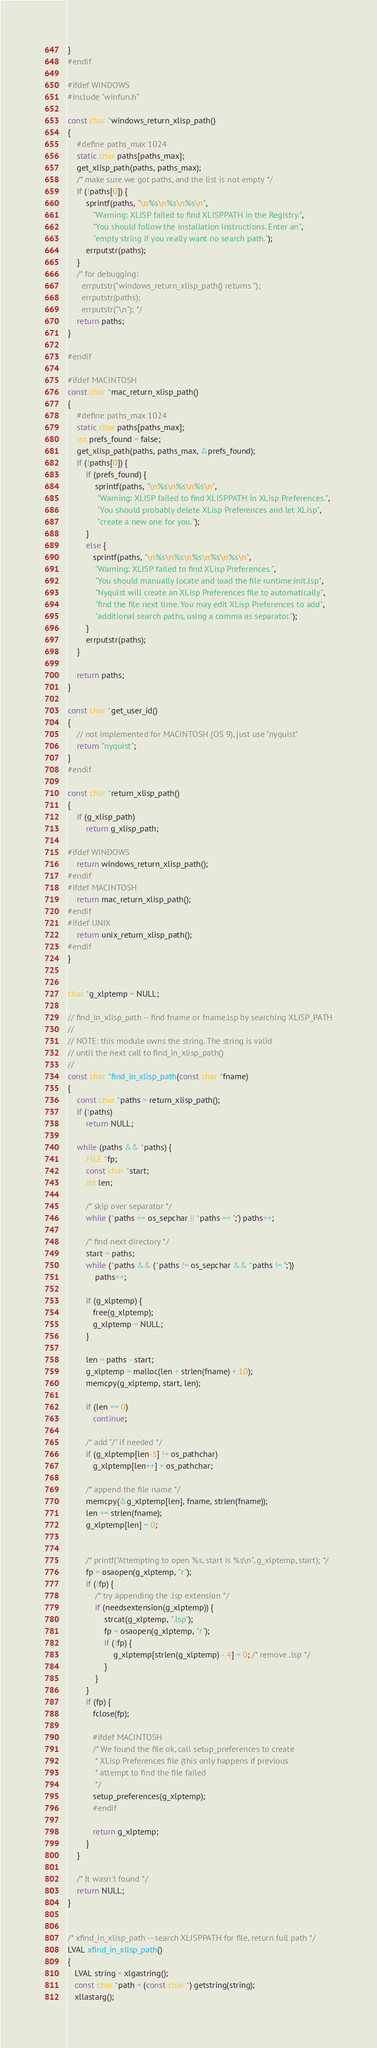Convert code to text. <code><loc_0><loc_0><loc_500><loc_500><_C_>}
#endif

#ifdef WINDOWS
#include "winfun.h"

const char *windows_return_xlisp_path()
{
    #define paths_max 1024
    static char paths[paths_max];
    get_xlisp_path(paths, paths_max);
    /* make sure we got paths, and the list is not empty */
    if (!paths[0]) {
        sprintf(paths, "\n%s\n%s\n%s\n",
           "Warning: XLISP failed to find XLISPPATH in the Registry.",
           "You should follow the installation instructions. Enter an",
           "empty string if you really want no search path.");
        errputstr(paths);
    }
    /* for debugging: 
      errputstr("windows_return_xlisp_path() returns ");
      errputstr(paths);
      errputstr("\n"); */
    return paths;
}

#endif

#ifdef MACINTOSH
const char *mac_return_xlisp_path()
{
    #define paths_max 1024
    static char paths[paths_max];
    int prefs_found = false;
    get_xlisp_path(paths, paths_max, &prefs_found);
    if (!paths[0]) {
        if (prefs_found) {
            sprintf(paths, "\n%s\n%s\n%s\n",
             "Warning: XLISP failed to find XLISPPATH in XLisp Preferences.",
             "You should probably delete XLisp Preferences and let XLisp",
             "create a new one for you.");
        }
        else {
           sprintf(paths, "\n%s\n%s\n%s\n%s\n%s\n",
            "Warning: XLISP failed to find XLisp Preferences.",
            "You should manually locate and load the file runtime:init.lsp",
            "Nyquist will create an XLisp Preferences file to automatically",
            "find the file next time. You may edit XLisp Preferences to add",
            "additional search paths, using a comma as separator.");
        }
        errputstr(paths);
    }

    return paths;
}

const char *get_user_id()
{
    // not implemented for MACINTOSH (OS 9), just use "nyquist"
    return "nyquist";
}
#endif

const char *return_xlisp_path()
{
    if (g_xlisp_path)
        return g_xlisp_path;

#ifdef WINDOWS
    return windows_return_xlisp_path();
#endif
#ifdef MACINTOSH
    return mac_return_xlisp_path();
#endif
#ifdef UNIX
    return unix_return_xlisp_path();
#endif
}


char *g_xlptemp = NULL;

// find_in_xlisp_path -- find fname or fname.lsp by searching XLISP_PATH
//
// NOTE: this module owns the string. The string is valid
// until the next call to find_in_xlisp_path()
//
const char *find_in_xlisp_path(const char *fname)
{
    const char *paths = return_xlisp_path();
    if (!paths)
        return NULL;

    while (paths && *paths) {
        FILE *fp;
        const char *start;
        int len;

        /* skip over separator */
        while (*paths == os_sepchar || *paths == ';') paths++;

        /* find next directory */
        start = paths;
        while (*paths && (*paths != os_sepchar && *paths != ';'))
            paths++;

        if (g_xlptemp) {
           free(g_xlptemp);
           g_xlptemp = NULL;
        }

        len = paths - start;
        g_xlptemp = malloc(len + strlen(fname) + 10);
        memcpy(g_xlptemp, start, len);

        if (len == 0)
           continue;

        /* add "/" if needed */
        if (g_xlptemp[len-1] != os_pathchar)
           g_xlptemp[len++] = os_pathchar;
        
        /* append the file name */
        memcpy(&g_xlptemp[len], fname, strlen(fname));
        len += strlen(fname);
        g_xlptemp[len] = 0;


        /* printf("Attempting to open %s, start is %s\n", g_xlptemp, start); */
        fp = osaopen(g_xlptemp, "r");
        if (!fp) {
            /* try appending the .lsp extension */
            if (needsextension(g_xlptemp)) {
                strcat(g_xlptemp, ".lsp");
                fp = osaopen(g_xlptemp, "r");
                if (!fp) {
                    g_xlptemp[strlen(g_xlptemp) - 4] = 0; /* remove .lsp */
                }
            }
        }
        if (fp) {
           fclose(fp);

           #ifdef MACINTOSH
           /* We found the file ok, call setup_preferences to create
            * XLisp Preferences file (this only happens if previous
            * attempt to find the file failed
            */
           setup_preferences(g_xlptemp);
           #endif

           return g_xlptemp;
        }
    }

    /* It wasn't found */
    return NULL;
}


/* xfind_in_xlisp_path -- search XLISPPATH for file, return full path */
LVAL xfind_in_xlisp_path()
{
   LVAL string = xlgastring();
   const char *path = (const char *) getstring(string);
   xllastarg();</code> 